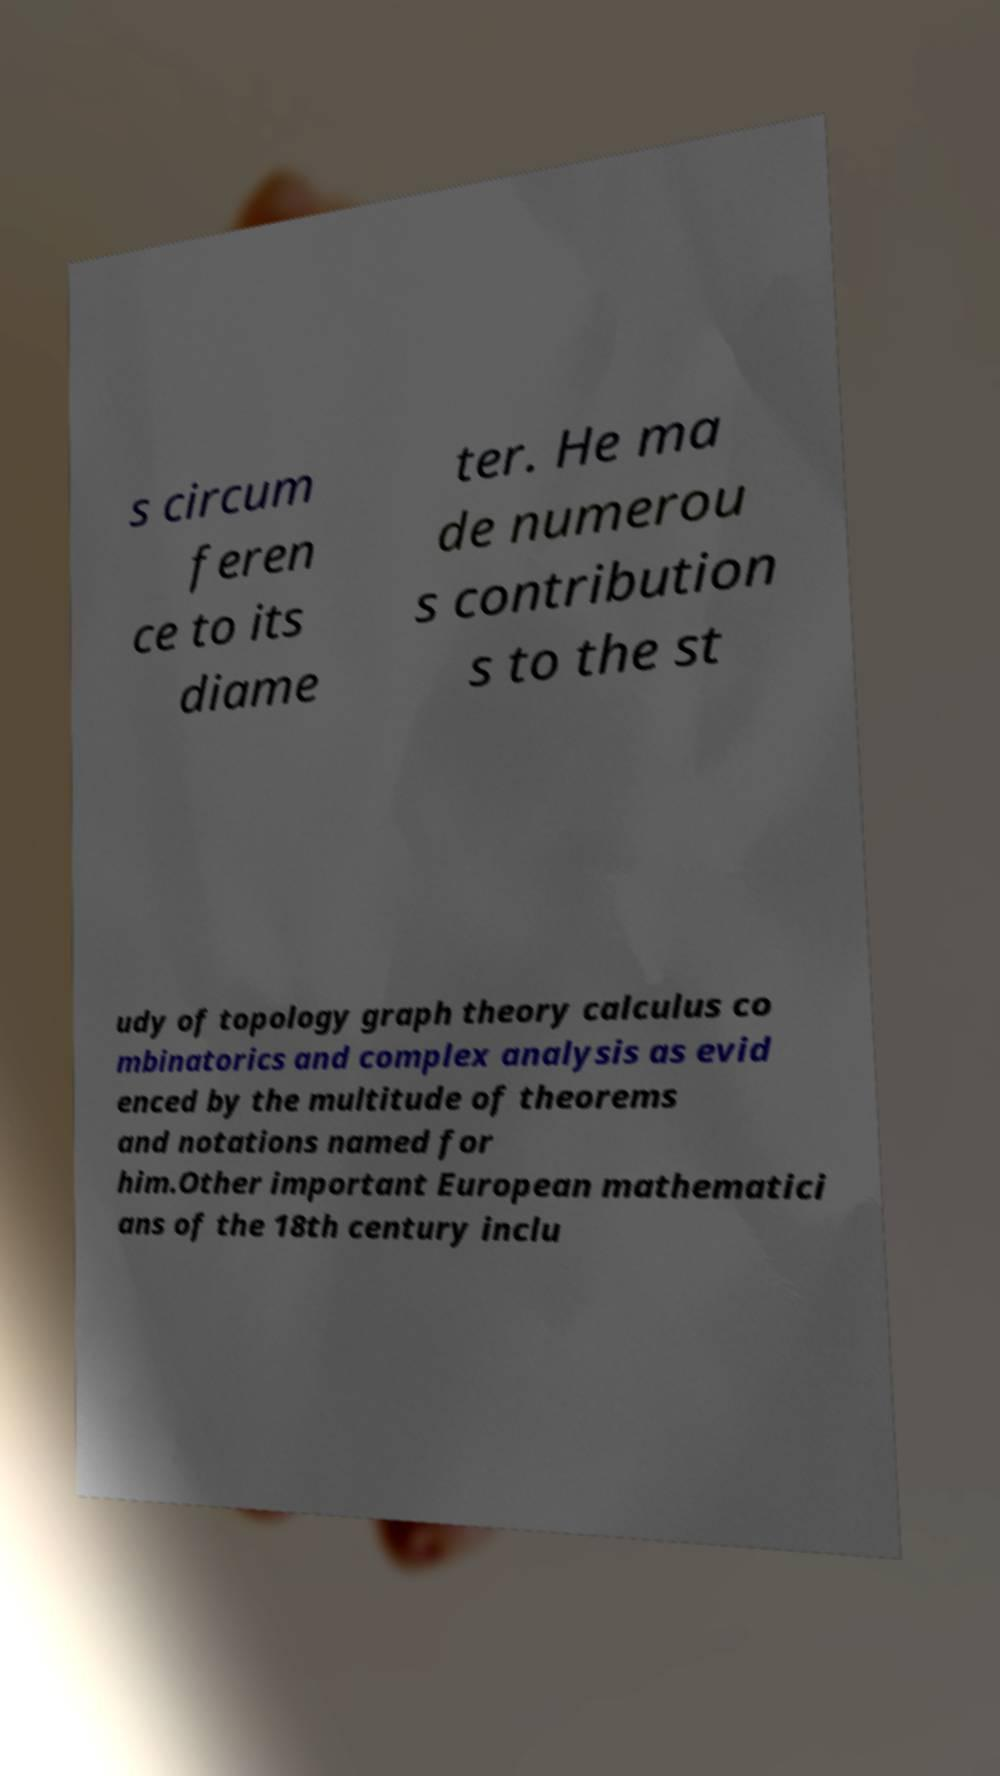Please read and relay the text visible in this image. What does it say? s circum feren ce to its diame ter. He ma de numerou s contribution s to the st udy of topology graph theory calculus co mbinatorics and complex analysis as evid enced by the multitude of theorems and notations named for him.Other important European mathematici ans of the 18th century inclu 